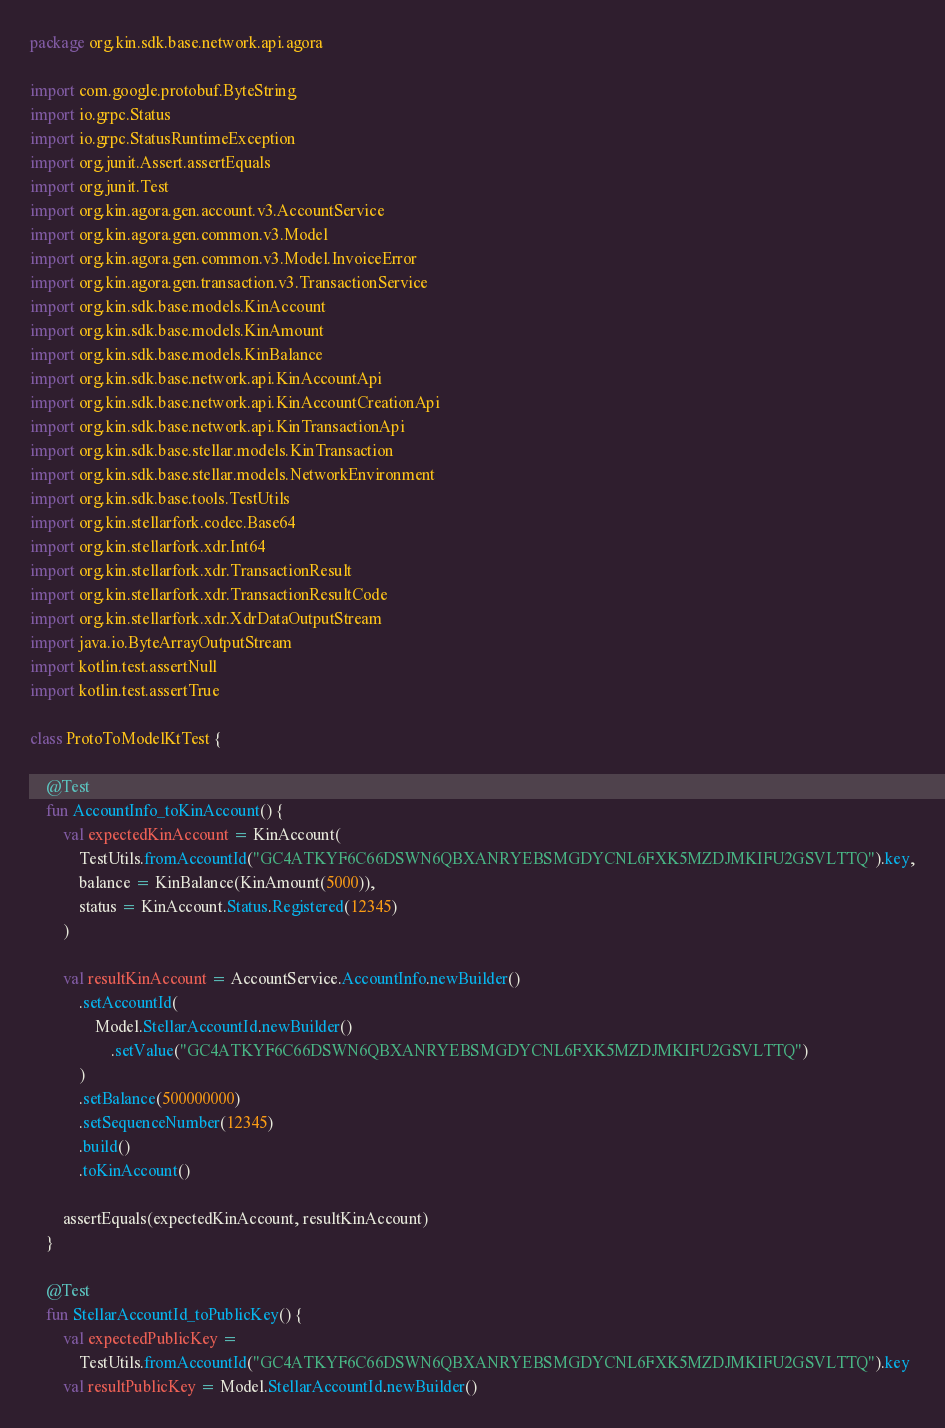<code> <loc_0><loc_0><loc_500><loc_500><_Kotlin_>package org.kin.sdk.base.network.api.agora

import com.google.protobuf.ByteString
import io.grpc.Status
import io.grpc.StatusRuntimeException
import org.junit.Assert.assertEquals
import org.junit.Test
import org.kin.agora.gen.account.v3.AccountService
import org.kin.agora.gen.common.v3.Model
import org.kin.agora.gen.common.v3.Model.InvoiceError
import org.kin.agora.gen.transaction.v3.TransactionService
import org.kin.sdk.base.models.KinAccount
import org.kin.sdk.base.models.KinAmount
import org.kin.sdk.base.models.KinBalance
import org.kin.sdk.base.network.api.KinAccountApi
import org.kin.sdk.base.network.api.KinAccountCreationApi
import org.kin.sdk.base.network.api.KinTransactionApi
import org.kin.sdk.base.stellar.models.KinTransaction
import org.kin.sdk.base.stellar.models.NetworkEnvironment
import org.kin.sdk.base.tools.TestUtils
import org.kin.stellarfork.codec.Base64
import org.kin.stellarfork.xdr.Int64
import org.kin.stellarfork.xdr.TransactionResult
import org.kin.stellarfork.xdr.TransactionResultCode
import org.kin.stellarfork.xdr.XdrDataOutputStream
import java.io.ByteArrayOutputStream
import kotlin.test.assertNull
import kotlin.test.assertTrue

class ProtoToModelKtTest {

    @Test
    fun AccountInfo_toKinAccount() {
        val expectedKinAccount = KinAccount(
            TestUtils.fromAccountId("GC4ATKYF6C66DSWN6QBXANRYEBSMGDYCNL6FXK5MZDJMKIFU2GSVLTTQ").key,
            balance = KinBalance(KinAmount(5000)),
            status = KinAccount.Status.Registered(12345)
        )

        val resultKinAccount = AccountService.AccountInfo.newBuilder()
            .setAccountId(
                Model.StellarAccountId.newBuilder()
                    .setValue("GC4ATKYF6C66DSWN6QBXANRYEBSMGDYCNL6FXK5MZDJMKIFU2GSVLTTQ")
            )
            .setBalance(500000000)
            .setSequenceNumber(12345)
            .build()
            .toKinAccount()

        assertEquals(expectedKinAccount, resultKinAccount)
    }

    @Test
    fun StellarAccountId_toPublicKey() {
        val expectedPublicKey =
            TestUtils.fromAccountId("GC4ATKYF6C66DSWN6QBXANRYEBSMGDYCNL6FXK5MZDJMKIFU2GSVLTTQ").key
        val resultPublicKey = Model.StellarAccountId.newBuilder()</code> 